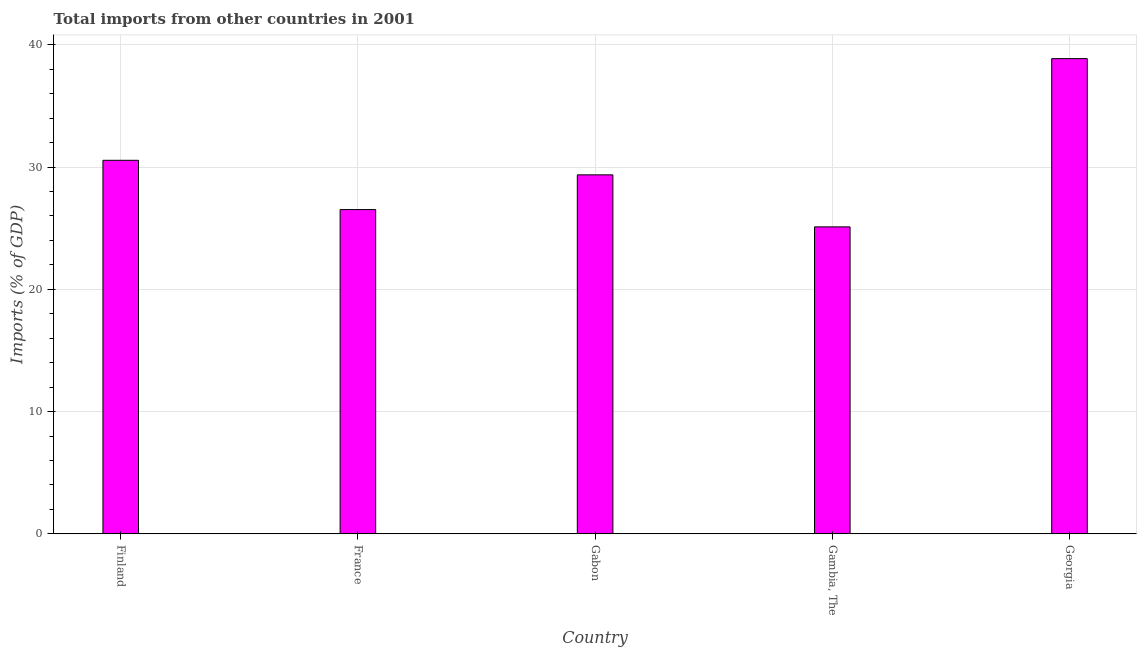What is the title of the graph?
Offer a terse response. Total imports from other countries in 2001. What is the label or title of the Y-axis?
Ensure brevity in your answer.  Imports (% of GDP). What is the total imports in Gambia, The?
Your response must be concise. 25.11. Across all countries, what is the maximum total imports?
Your answer should be very brief. 38.87. Across all countries, what is the minimum total imports?
Offer a very short reply. 25.11. In which country was the total imports maximum?
Your answer should be very brief. Georgia. In which country was the total imports minimum?
Make the answer very short. Gambia, The. What is the sum of the total imports?
Offer a very short reply. 150.42. What is the difference between the total imports in Finland and Gabon?
Ensure brevity in your answer.  1.19. What is the average total imports per country?
Make the answer very short. 30.08. What is the median total imports?
Ensure brevity in your answer.  29.36. In how many countries, is the total imports greater than 10 %?
Give a very brief answer. 5. What is the ratio of the total imports in Finland to that in France?
Offer a very short reply. 1.15. Is the difference between the total imports in France and Georgia greater than the difference between any two countries?
Make the answer very short. No. What is the difference between the highest and the second highest total imports?
Make the answer very short. 8.31. What is the difference between the highest and the lowest total imports?
Make the answer very short. 13.76. Are all the bars in the graph horizontal?
Provide a succinct answer. No. How many countries are there in the graph?
Your response must be concise. 5. What is the Imports (% of GDP) in Finland?
Offer a terse response. 30.55. What is the Imports (% of GDP) of France?
Keep it short and to the point. 26.52. What is the Imports (% of GDP) in Gabon?
Keep it short and to the point. 29.36. What is the Imports (% of GDP) in Gambia, The?
Give a very brief answer. 25.11. What is the Imports (% of GDP) in Georgia?
Provide a short and direct response. 38.87. What is the difference between the Imports (% of GDP) in Finland and France?
Your answer should be very brief. 4.03. What is the difference between the Imports (% of GDP) in Finland and Gabon?
Make the answer very short. 1.19. What is the difference between the Imports (% of GDP) in Finland and Gambia, The?
Provide a short and direct response. 5.44. What is the difference between the Imports (% of GDP) in Finland and Georgia?
Your answer should be very brief. -8.32. What is the difference between the Imports (% of GDP) in France and Gabon?
Provide a succinct answer. -2.84. What is the difference between the Imports (% of GDP) in France and Gambia, The?
Provide a short and direct response. 1.41. What is the difference between the Imports (% of GDP) in France and Georgia?
Your answer should be very brief. -12.35. What is the difference between the Imports (% of GDP) in Gabon and Gambia, The?
Make the answer very short. 4.25. What is the difference between the Imports (% of GDP) in Gabon and Georgia?
Provide a short and direct response. -9.51. What is the difference between the Imports (% of GDP) in Gambia, The and Georgia?
Give a very brief answer. -13.76. What is the ratio of the Imports (% of GDP) in Finland to that in France?
Provide a short and direct response. 1.15. What is the ratio of the Imports (% of GDP) in Finland to that in Gabon?
Make the answer very short. 1.04. What is the ratio of the Imports (% of GDP) in Finland to that in Gambia, The?
Offer a very short reply. 1.22. What is the ratio of the Imports (% of GDP) in Finland to that in Georgia?
Make the answer very short. 0.79. What is the ratio of the Imports (% of GDP) in France to that in Gabon?
Offer a terse response. 0.9. What is the ratio of the Imports (% of GDP) in France to that in Gambia, The?
Offer a very short reply. 1.06. What is the ratio of the Imports (% of GDP) in France to that in Georgia?
Ensure brevity in your answer.  0.68. What is the ratio of the Imports (% of GDP) in Gabon to that in Gambia, The?
Ensure brevity in your answer.  1.17. What is the ratio of the Imports (% of GDP) in Gabon to that in Georgia?
Make the answer very short. 0.76. What is the ratio of the Imports (% of GDP) in Gambia, The to that in Georgia?
Your response must be concise. 0.65. 